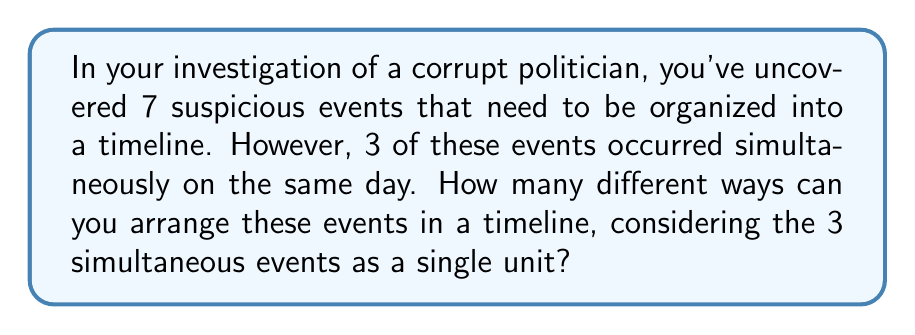Provide a solution to this math problem. Let's approach this step-by-step:

1) We have 7 total events, but 3 of them are simultaneous. This means we're essentially arranging 5 distinct units:
   - The 3 simultaneous events (as one unit)
   - The other 4 individual events

2) To find the number of ways to arrange these 5 units, we use the formula for permutations:

   $$P(n) = n!$$

   Where $n$ is the number of distinct items to be arranged.

3) In this case, $n = 5$, so we have:

   $$P(5) = 5! = 5 \times 4 \times 3 \times 2 \times 1 = 120$$

4) However, we're not done yet. The 3 simultaneous events can also be arranged among themselves in different ways. This is another permutation:

   $$P(3) = 3! = 3 \times 2 \times 1 = 6$$

5) By the multiplication principle, the total number of possible arrangements is the product of the number of ways to arrange the 5 units and the number of ways to arrange the 3 simultaneous events within their unit:

   $$\text{Total arrangements} = 5! \times 3! = 120 \times 6 = 720$$

Therefore, there are 720 different ways to arrange these events in a timeline.
Answer: 720 